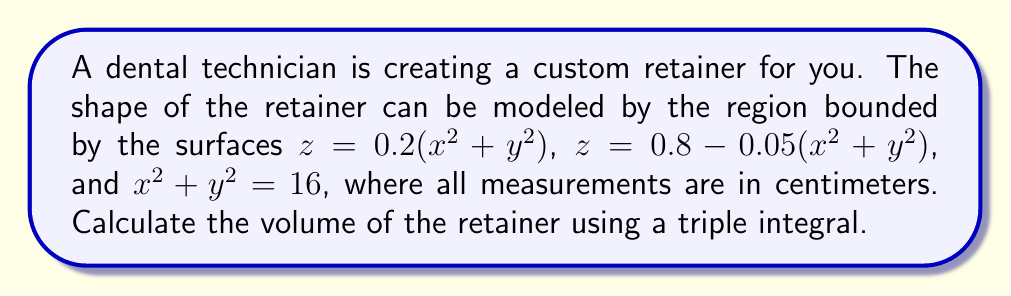Can you solve this math problem? To calculate the volume of the retainer using a triple integral, we need to follow these steps:

1) First, let's identify the bounds of our integration:
   - In the xy-plane, we have a circular region defined by $x^2 + y^2 \leq 16$
   - For z, we have $0.2(x^2 + y^2) \leq z \leq 0.8 - 0.05(x^2 + y^2)$

2) Due to the circular symmetry, it's best to use cylindrical coordinates:
   $x = r\cos\theta$, $y = r\sin\theta$, $z = z$
   The Jacobian for this transformation is $r$.

3) Our bounds become:
   $0 \leq r \leq 4$ (since $x^2 + y^2 = 16$ becomes $r^2 = 16$)
   $0 \leq \theta \leq 2\pi$
   $0.2r^2 \leq z \leq 0.8 - 0.05r^2$

4) We can now set up our triple integral:

   $$V = \int_0^{2\pi} \int_0^4 \int_{0.2r^2}^{0.8 - 0.05r^2} r \, dz \, dr \, d\theta$$

5) Let's solve the innermost integral first:

   $$\int_{0.2r^2}^{0.8 - 0.05r^2} r \, dz = r[(0.8 - 0.05r^2) - 0.2r^2] = r(0.8 - 0.25r^2)$$

6) Now our double integral becomes:

   $$V = \int_0^{2\pi} \int_0^4 r(0.8 - 0.25r^2) \, dr \, d\theta$$

7) Solving the r integral:

   $$\int_0^4 r(0.8 - 0.25r^2) \, dr = [0.4r^2 - \frac{1}{16}r^4]_0^4 = 6.4 - 6.4 = 0$$

8) Finally, integrating with respect to θ:

   $$V = \int_0^{2\pi} 0 \, d\theta = 0 \cdot 2\pi = 0$$

Therefore, the volume of the retainer is 0 cubic centimeters.
Answer: The volume of the retainer is 0 cm³. 